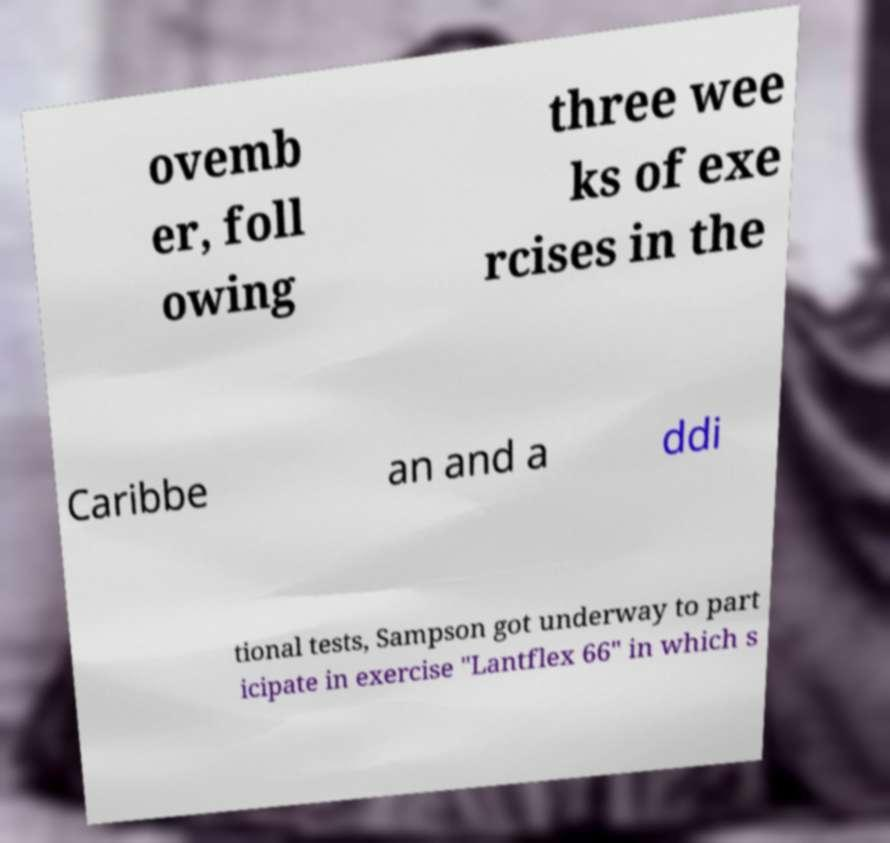Please read and relay the text visible in this image. What does it say? ovemb er, foll owing three wee ks of exe rcises in the Caribbe an and a ddi tional tests, Sampson got underway to part icipate in exercise "Lantflex 66" in which s 